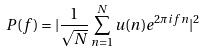Convert formula to latex. <formula><loc_0><loc_0><loc_500><loc_500>P ( f ) = | \frac { 1 } { \sqrt { N } } \sum _ { n = 1 } ^ { N } u ( n ) e ^ { 2 \pi i f n } | ^ { 2 }</formula> 